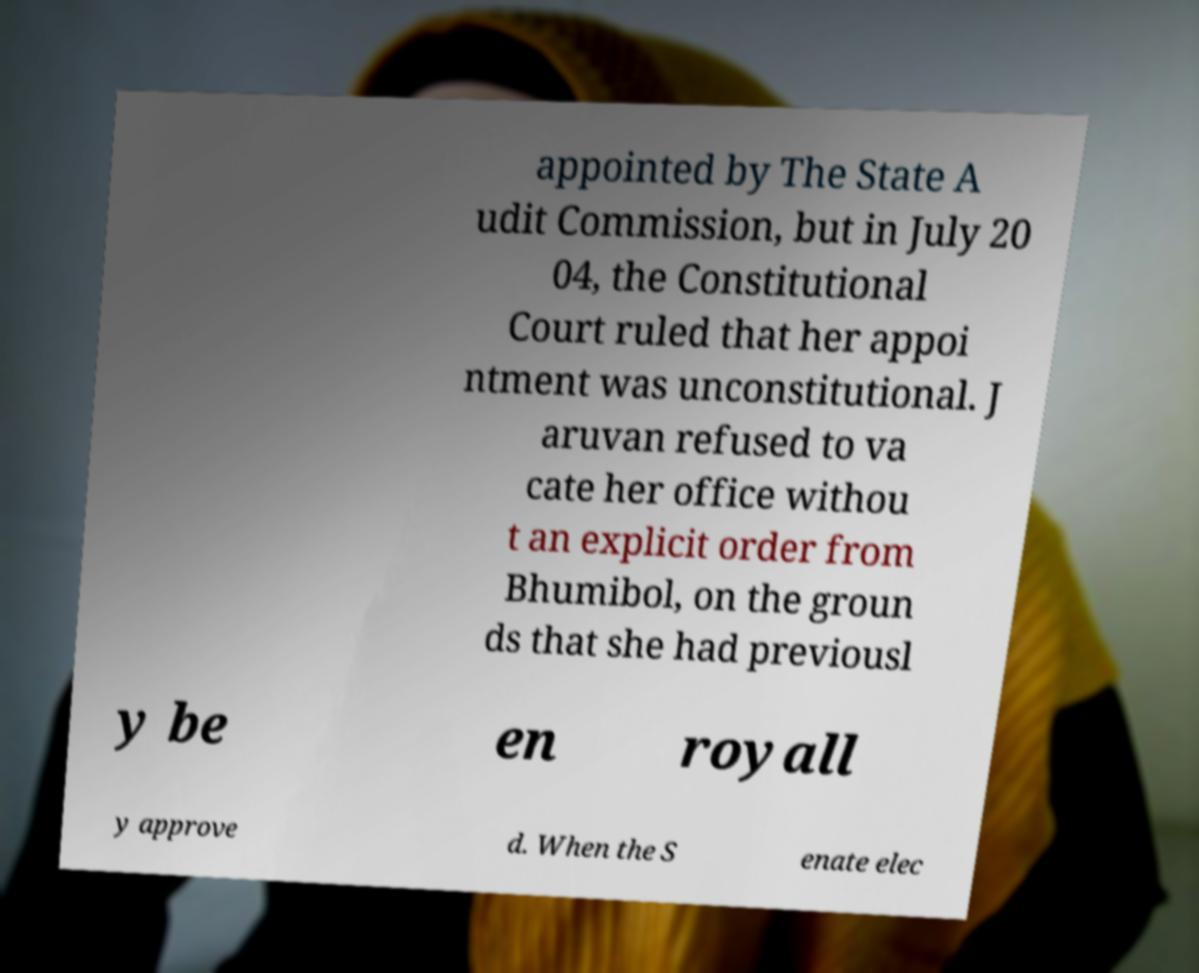There's text embedded in this image that I need extracted. Can you transcribe it verbatim? appointed by The State A udit Commission, but in July 20 04, the Constitutional Court ruled that her appoi ntment was unconstitutional. J aruvan refused to va cate her office withou t an explicit order from Bhumibol, on the groun ds that she had previousl y be en royall y approve d. When the S enate elec 